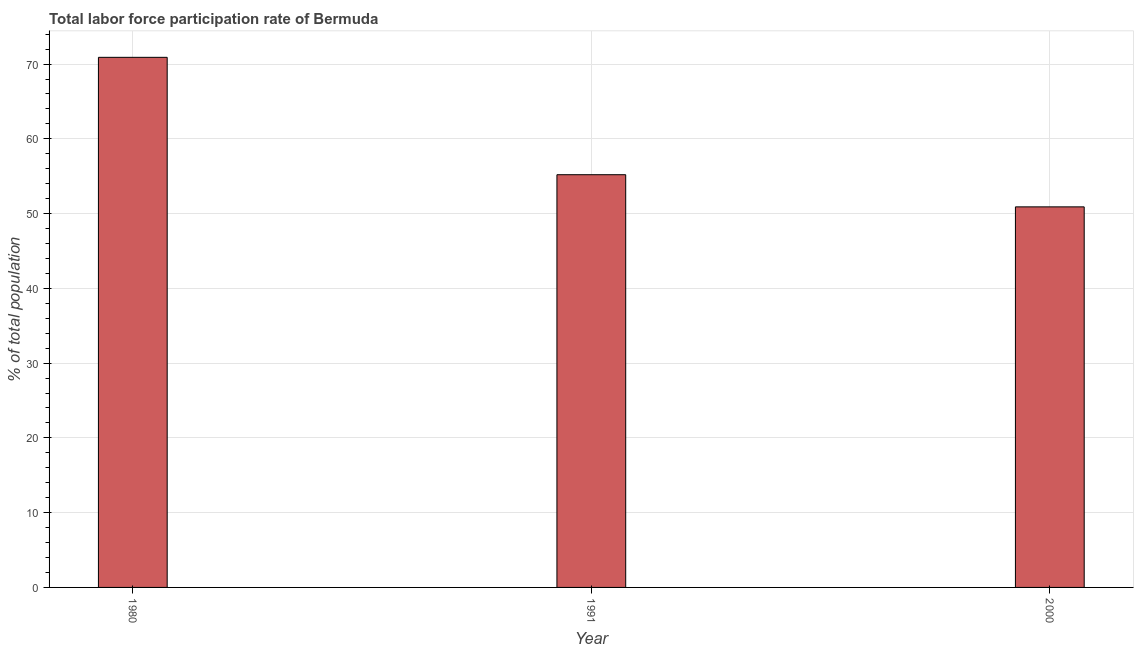Does the graph contain any zero values?
Your response must be concise. No. Does the graph contain grids?
Make the answer very short. Yes. What is the title of the graph?
Provide a succinct answer. Total labor force participation rate of Bermuda. What is the label or title of the Y-axis?
Give a very brief answer. % of total population. What is the total labor force participation rate in 1991?
Provide a succinct answer. 55.2. Across all years, what is the maximum total labor force participation rate?
Ensure brevity in your answer.  70.9. Across all years, what is the minimum total labor force participation rate?
Give a very brief answer. 50.9. What is the sum of the total labor force participation rate?
Keep it short and to the point. 177. What is the difference between the total labor force participation rate in 1980 and 2000?
Ensure brevity in your answer.  20. What is the average total labor force participation rate per year?
Make the answer very short. 59. What is the median total labor force participation rate?
Make the answer very short. 55.2. Do a majority of the years between 1991 and 2000 (inclusive) have total labor force participation rate greater than 68 %?
Your response must be concise. No. What is the ratio of the total labor force participation rate in 1980 to that in 2000?
Make the answer very short. 1.39. Is the difference between the total labor force participation rate in 1980 and 1991 greater than the difference between any two years?
Offer a very short reply. No. In how many years, is the total labor force participation rate greater than the average total labor force participation rate taken over all years?
Offer a terse response. 1. What is the difference between two consecutive major ticks on the Y-axis?
Give a very brief answer. 10. What is the % of total population in 1980?
Your answer should be very brief. 70.9. What is the % of total population in 1991?
Make the answer very short. 55.2. What is the % of total population of 2000?
Your response must be concise. 50.9. What is the ratio of the % of total population in 1980 to that in 1991?
Provide a succinct answer. 1.28. What is the ratio of the % of total population in 1980 to that in 2000?
Keep it short and to the point. 1.39. What is the ratio of the % of total population in 1991 to that in 2000?
Provide a short and direct response. 1.08. 